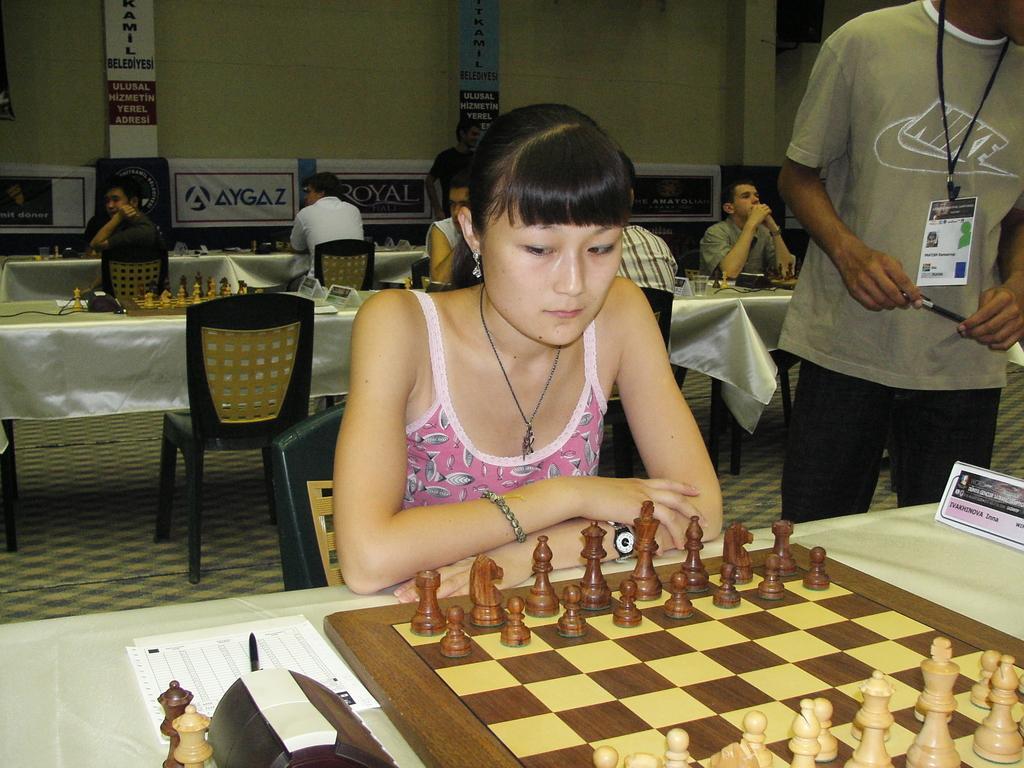Can you describe this image briefly? In this image i can a woman playing the chess beside the woman there is man wearing the identity card holding the pen,here on the table i can see a paper and a pen. At the back of the woman there are some man setting and playing the chess and at the background there is wall and banners attached to it. 